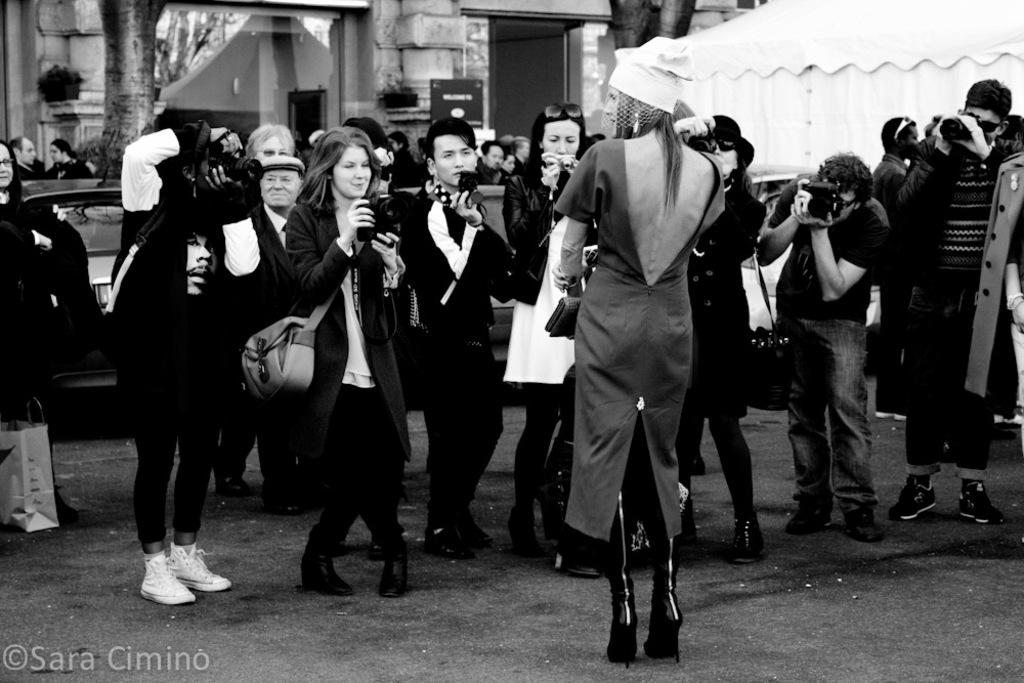What is the color scheme of the image? The image is black and white. What is the main subject in the image? There is a beautiful woman standing in the middle of the image. What are the people on the left side of the image doing? The people on the left side of the image are taking photographs of the woman. What can be seen behind the people in the image? There is a car visible behind the people. How does the goldfish contribute to the overall effect of the image? There is no goldfish present in the image, so it cannot contribute to the overall effect. 